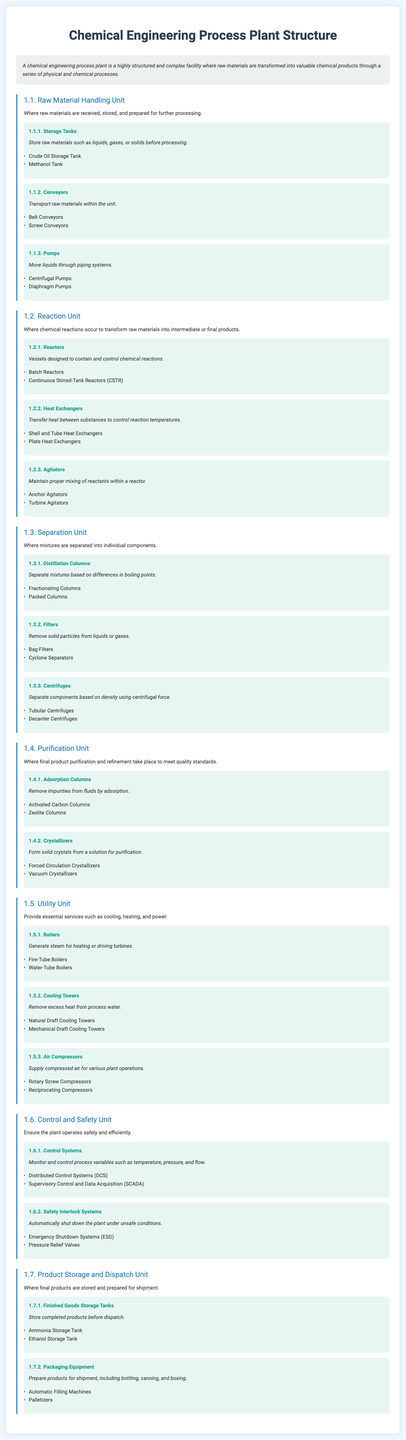what is the title of the document? The title is displayed prominently at the top of the document, stating the topic being presented.
Answer: Chemical Engineering Process Plant Structure what is the first unit mentioned in the document? The first unit is identified in the hierarchical structure, listing the primary functional groups of the plant.
Answer: Raw Material Handling Unit how many types of equipment are listed under the Reaction Unit? The number of equipment types can be counted from the section detailing the equipment associated with the Reaction Unit.
Answer: 3 what is the functional role of Heat Exchangers? The functional role describes the main purpose of the equipment in the chemical engineering process.
Answer: Transfer heat between substances to control reaction temperatures which unit provides steam for heating? The respective unit is specified in the document that focuses on utilities required for the overall operation of the plant.
Answer: Utility Unit name one type of storage tank listed under the Product Storage and Dispatch Unit. The document enumerates specific examples in the context of product storage, focusing on the handling of finished goods.
Answer: Ammonia Storage Tank what is the purpose of Control Systems in a chemical engineering process plant? The purpose delineated in the document outlines the key functions that control systems serve within the process plant.
Answer: Monitor and control process variables such as temperature, pressure, and flow how many units are discussed in the document? The total number of units can be calculated based on the distinct sections presented throughout the infographic.
Answer: 7 